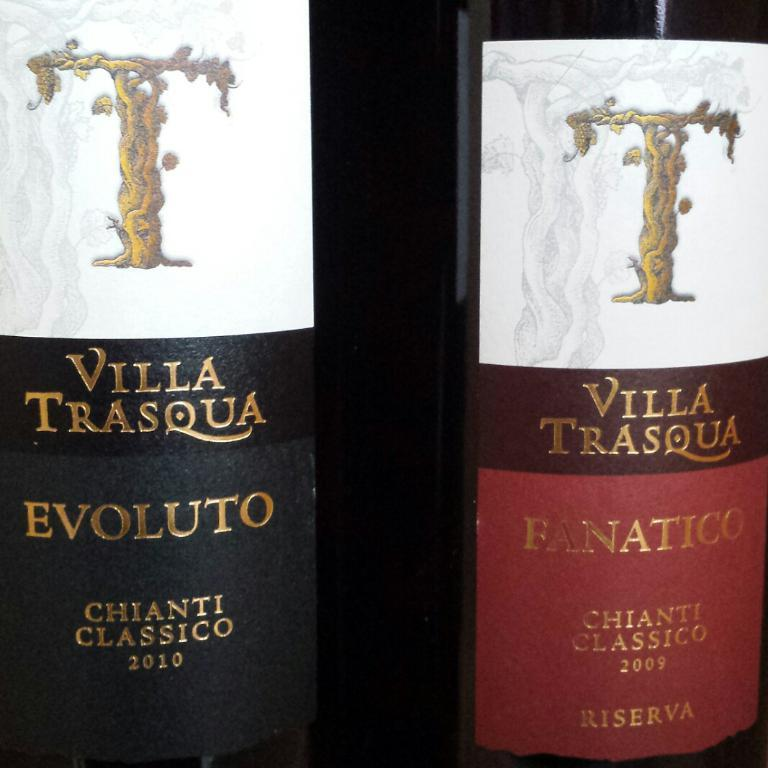<image>
Render a clear and concise summary of the photo. Two bottles of "VILLA TRASQUA" are next to each other. 